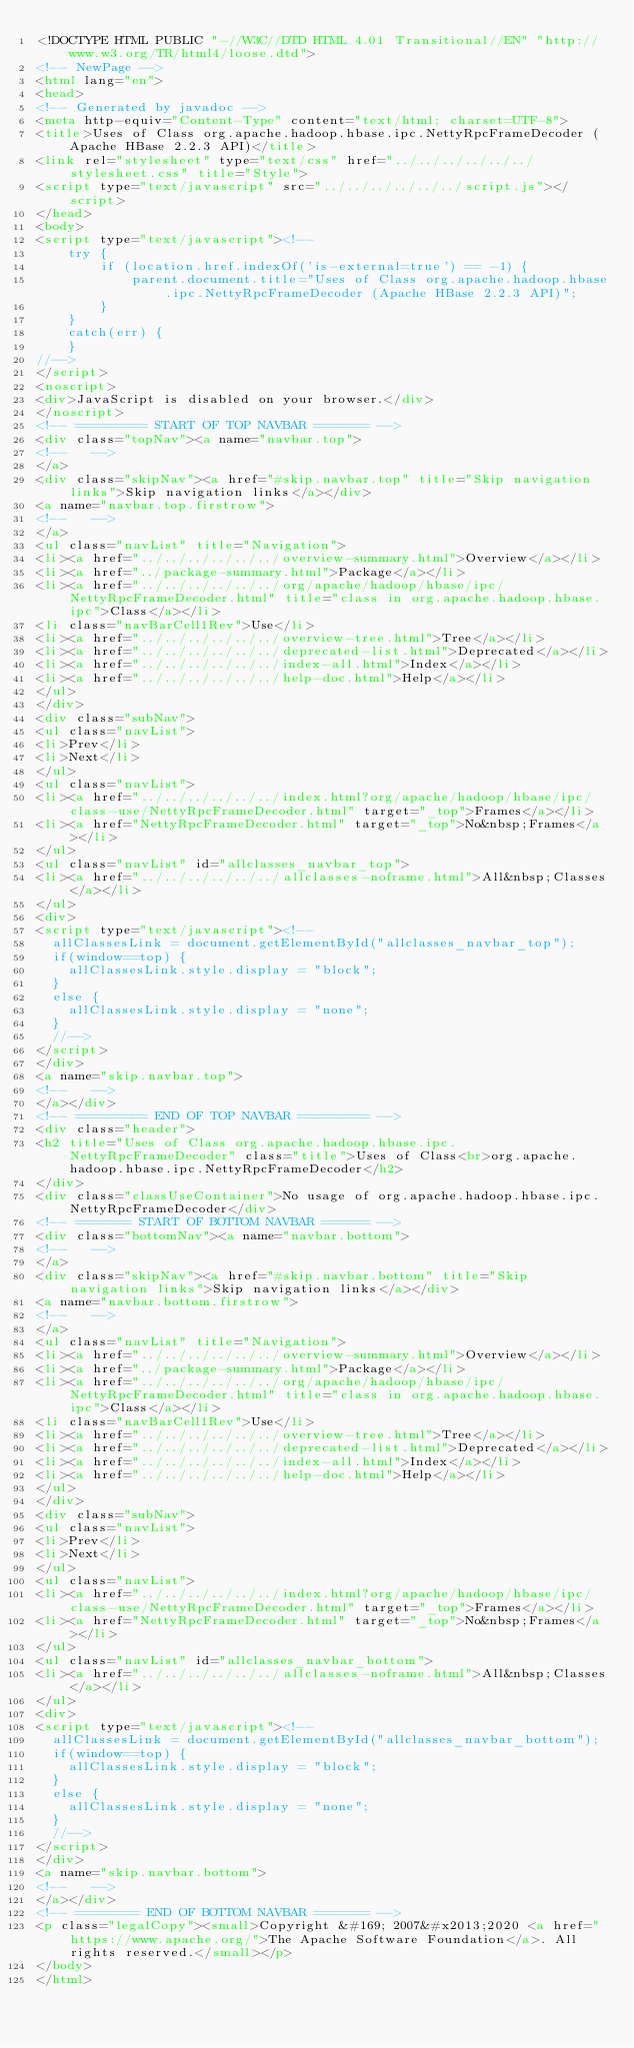<code> <loc_0><loc_0><loc_500><loc_500><_HTML_><!DOCTYPE HTML PUBLIC "-//W3C//DTD HTML 4.01 Transitional//EN" "http://www.w3.org/TR/html4/loose.dtd">
<!-- NewPage -->
<html lang="en">
<head>
<!-- Generated by javadoc -->
<meta http-equiv="Content-Type" content="text/html; charset=UTF-8">
<title>Uses of Class org.apache.hadoop.hbase.ipc.NettyRpcFrameDecoder (Apache HBase 2.2.3 API)</title>
<link rel="stylesheet" type="text/css" href="../../../../../../stylesheet.css" title="Style">
<script type="text/javascript" src="../../../../../../script.js"></script>
</head>
<body>
<script type="text/javascript"><!--
    try {
        if (location.href.indexOf('is-external=true') == -1) {
            parent.document.title="Uses of Class org.apache.hadoop.hbase.ipc.NettyRpcFrameDecoder (Apache HBase 2.2.3 API)";
        }
    }
    catch(err) {
    }
//-->
</script>
<noscript>
<div>JavaScript is disabled on your browser.</div>
</noscript>
<!-- ========= START OF TOP NAVBAR ======= -->
<div class="topNav"><a name="navbar.top">
<!--   -->
</a>
<div class="skipNav"><a href="#skip.navbar.top" title="Skip navigation links">Skip navigation links</a></div>
<a name="navbar.top.firstrow">
<!--   -->
</a>
<ul class="navList" title="Navigation">
<li><a href="../../../../../../overview-summary.html">Overview</a></li>
<li><a href="../package-summary.html">Package</a></li>
<li><a href="../../../../../../org/apache/hadoop/hbase/ipc/NettyRpcFrameDecoder.html" title="class in org.apache.hadoop.hbase.ipc">Class</a></li>
<li class="navBarCell1Rev">Use</li>
<li><a href="../../../../../../overview-tree.html">Tree</a></li>
<li><a href="../../../../../../deprecated-list.html">Deprecated</a></li>
<li><a href="../../../../../../index-all.html">Index</a></li>
<li><a href="../../../../../../help-doc.html">Help</a></li>
</ul>
</div>
<div class="subNav">
<ul class="navList">
<li>Prev</li>
<li>Next</li>
</ul>
<ul class="navList">
<li><a href="../../../../../../index.html?org/apache/hadoop/hbase/ipc/class-use/NettyRpcFrameDecoder.html" target="_top">Frames</a></li>
<li><a href="NettyRpcFrameDecoder.html" target="_top">No&nbsp;Frames</a></li>
</ul>
<ul class="navList" id="allclasses_navbar_top">
<li><a href="../../../../../../allclasses-noframe.html">All&nbsp;Classes</a></li>
</ul>
<div>
<script type="text/javascript"><!--
  allClassesLink = document.getElementById("allclasses_navbar_top");
  if(window==top) {
    allClassesLink.style.display = "block";
  }
  else {
    allClassesLink.style.display = "none";
  }
  //-->
</script>
</div>
<a name="skip.navbar.top">
<!--   -->
</a></div>
<!-- ========= END OF TOP NAVBAR ========= -->
<div class="header">
<h2 title="Uses of Class org.apache.hadoop.hbase.ipc.NettyRpcFrameDecoder" class="title">Uses of Class<br>org.apache.hadoop.hbase.ipc.NettyRpcFrameDecoder</h2>
</div>
<div class="classUseContainer">No usage of org.apache.hadoop.hbase.ipc.NettyRpcFrameDecoder</div>
<!-- ======= START OF BOTTOM NAVBAR ====== -->
<div class="bottomNav"><a name="navbar.bottom">
<!--   -->
</a>
<div class="skipNav"><a href="#skip.navbar.bottom" title="Skip navigation links">Skip navigation links</a></div>
<a name="navbar.bottom.firstrow">
<!--   -->
</a>
<ul class="navList" title="Navigation">
<li><a href="../../../../../../overview-summary.html">Overview</a></li>
<li><a href="../package-summary.html">Package</a></li>
<li><a href="../../../../../../org/apache/hadoop/hbase/ipc/NettyRpcFrameDecoder.html" title="class in org.apache.hadoop.hbase.ipc">Class</a></li>
<li class="navBarCell1Rev">Use</li>
<li><a href="../../../../../../overview-tree.html">Tree</a></li>
<li><a href="../../../../../../deprecated-list.html">Deprecated</a></li>
<li><a href="../../../../../../index-all.html">Index</a></li>
<li><a href="../../../../../../help-doc.html">Help</a></li>
</ul>
</div>
<div class="subNav">
<ul class="navList">
<li>Prev</li>
<li>Next</li>
</ul>
<ul class="navList">
<li><a href="../../../../../../index.html?org/apache/hadoop/hbase/ipc/class-use/NettyRpcFrameDecoder.html" target="_top">Frames</a></li>
<li><a href="NettyRpcFrameDecoder.html" target="_top">No&nbsp;Frames</a></li>
</ul>
<ul class="navList" id="allclasses_navbar_bottom">
<li><a href="../../../../../../allclasses-noframe.html">All&nbsp;Classes</a></li>
</ul>
<div>
<script type="text/javascript"><!--
  allClassesLink = document.getElementById("allclasses_navbar_bottom");
  if(window==top) {
    allClassesLink.style.display = "block";
  }
  else {
    allClassesLink.style.display = "none";
  }
  //-->
</script>
</div>
<a name="skip.navbar.bottom">
<!--   -->
</a></div>
<!-- ======== END OF BOTTOM NAVBAR ======= -->
<p class="legalCopy"><small>Copyright &#169; 2007&#x2013;2020 <a href="https://www.apache.org/">The Apache Software Foundation</a>. All rights reserved.</small></p>
</body>
</html>
</code> 